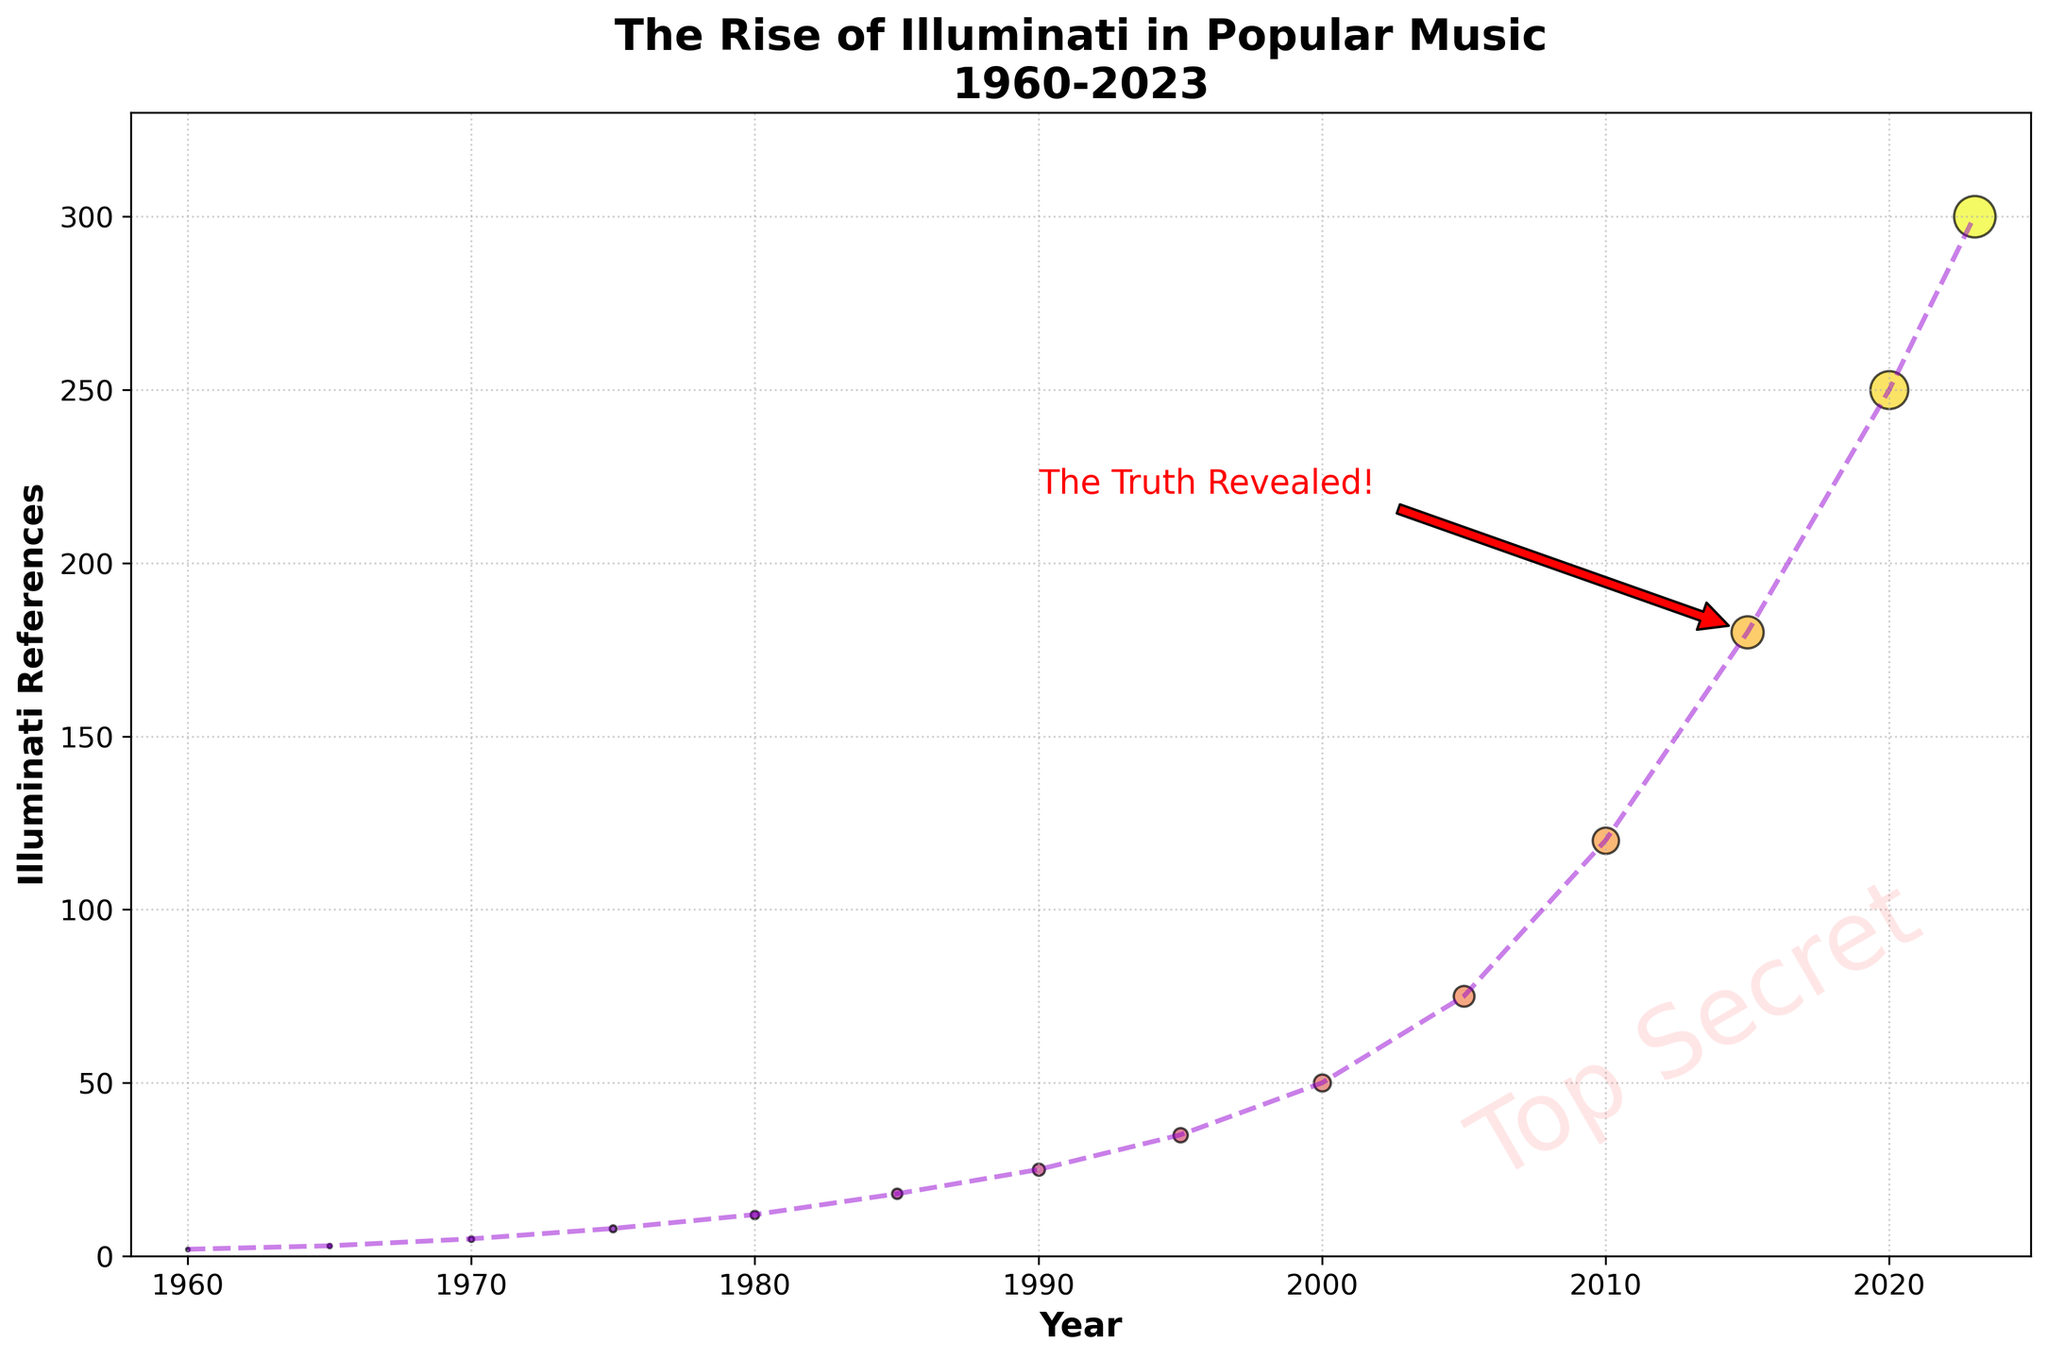What was the trend of Illuminati references from 1960 to 2023? Observing the line chart, the trend shows a consistent increase in Illuminati references over time. Starting from just 2 in 1960 and rising to 300 in 2023, the growth is particularly sharp from 2000 onwards.
Answer: Consistent increase Which year had the most notable jump in Illuminati references compared to the previous decade? By examining the points and the increment between decades, the most notable jump is seen between 2000 (50 references) and 2010 (120 references), a difference of 70. This is significantly larger than other decade-over-decade increases.
Answer: 2000 to 2010 How many Illuminati references were there in total from 1960 to 1980? We sum the references for the years 1960, 1965, 1970, 1975, and 1980 from the figure: 2 + 3 + 5 + 8 + 12 = 30.
Answer: 30 Comparing the years 1980 and 1995, which had a greater number of references and by how much? From the visualization, 1995 had 35 references and 1980 had 12 references. The difference is 35 - 12 = 23 references.
Answer: 1995 by 23 What visual elements emphasize the rise in Illuminati references around 2015? The annotation "The Truth Revealed!" with an arrow pointing to 2015 and the distinct change in color gradients as well as the marker size increase around that point emphasizes the rise in references.
Answer: Annotation and marker size How has the frequency of Illuminati references changed from the year 2000 to 2023? The references in 2000 were 50, and in 2023 they were 300, showing an increase of 250 over this period. The visual shows a steep rise in both the line and scatter plot markers.
Answer: Increased by 250 What is the percentage increase in Illuminati references from 2010 to 2023? The number of references grew from 120 in 2010 to 300 in 2023. The percentage increase is calculated as ((300 - 120) / 120) * 100% = 150%.
Answer: 150% Which year did the curve begin to steepen significantly? By looking at the line plot, it begins to steepen significantly around 2000, where the rise in references becomes more pronounced.
Answer: Around 2000 How many times greater were the references in 2023 compared to 1960? The references in 2023 were 300, and in 1960, they were 2. So, 300 divided by 2 is 150 times greater.
Answer: 150 times 